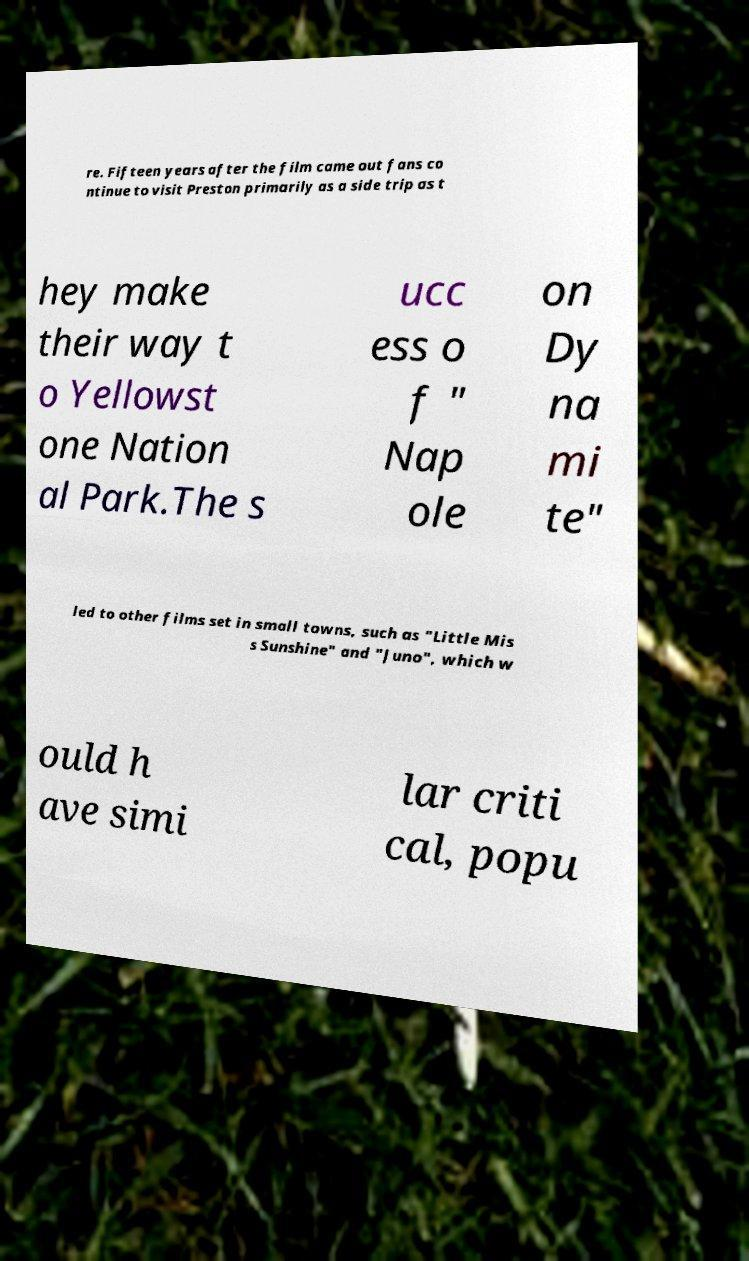For documentation purposes, I need the text within this image transcribed. Could you provide that? re. Fifteen years after the film came out fans co ntinue to visit Preston primarily as a side trip as t hey make their way t o Yellowst one Nation al Park.The s ucc ess o f " Nap ole on Dy na mi te" led to other films set in small towns, such as "Little Mis s Sunshine" and "Juno", which w ould h ave simi lar criti cal, popu 